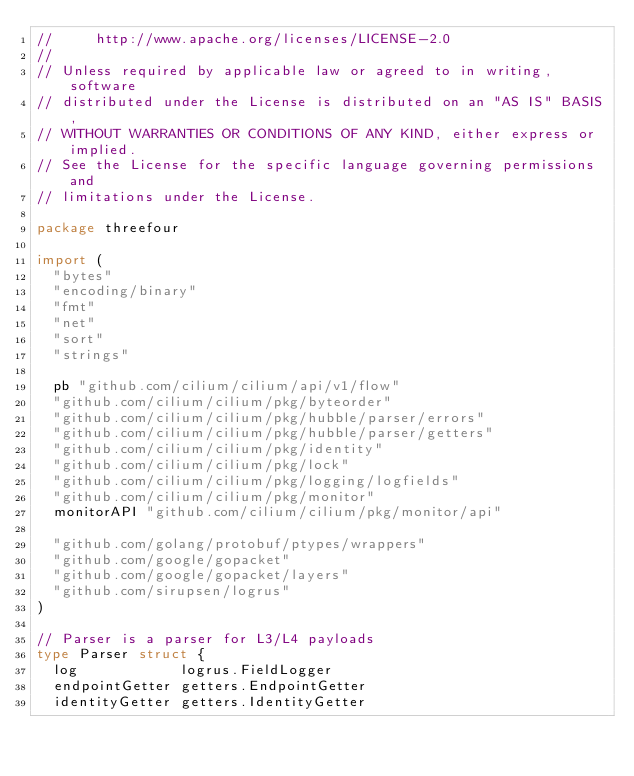<code> <loc_0><loc_0><loc_500><loc_500><_Go_>//     http://www.apache.org/licenses/LICENSE-2.0
//
// Unless required by applicable law or agreed to in writing, software
// distributed under the License is distributed on an "AS IS" BASIS,
// WITHOUT WARRANTIES OR CONDITIONS OF ANY KIND, either express or implied.
// See the License for the specific language governing permissions and
// limitations under the License.

package threefour

import (
	"bytes"
	"encoding/binary"
	"fmt"
	"net"
	"sort"
	"strings"

	pb "github.com/cilium/cilium/api/v1/flow"
	"github.com/cilium/cilium/pkg/byteorder"
	"github.com/cilium/cilium/pkg/hubble/parser/errors"
	"github.com/cilium/cilium/pkg/hubble/parser/getters"
	"github.com/cilium/cilium/pkg/identity"
	"github.com/cilium/cilium/pkg/lock"
	"github.com/cilium/cilium/pkg/logging/logfields"
	"github.com/cilium/cilium/pkg/monitor"
	monitorAPI "github.com/cilium/cilium/pkg/monitor/api"

	"github.com/golang/protobuf/ptypes/wrappers"
	"github.com/google/gopacket"
	"github.com/google/gopacket/layers"
	"github.com/sirupsen/logrus"
)

// Parser is a parser for L3/L4 payloads
type Parser struct {
	log            logrus.FieldLogger
	endpointGetter getters.EndpointGetter
	identityGetter getters.IdentityGetter</code> 